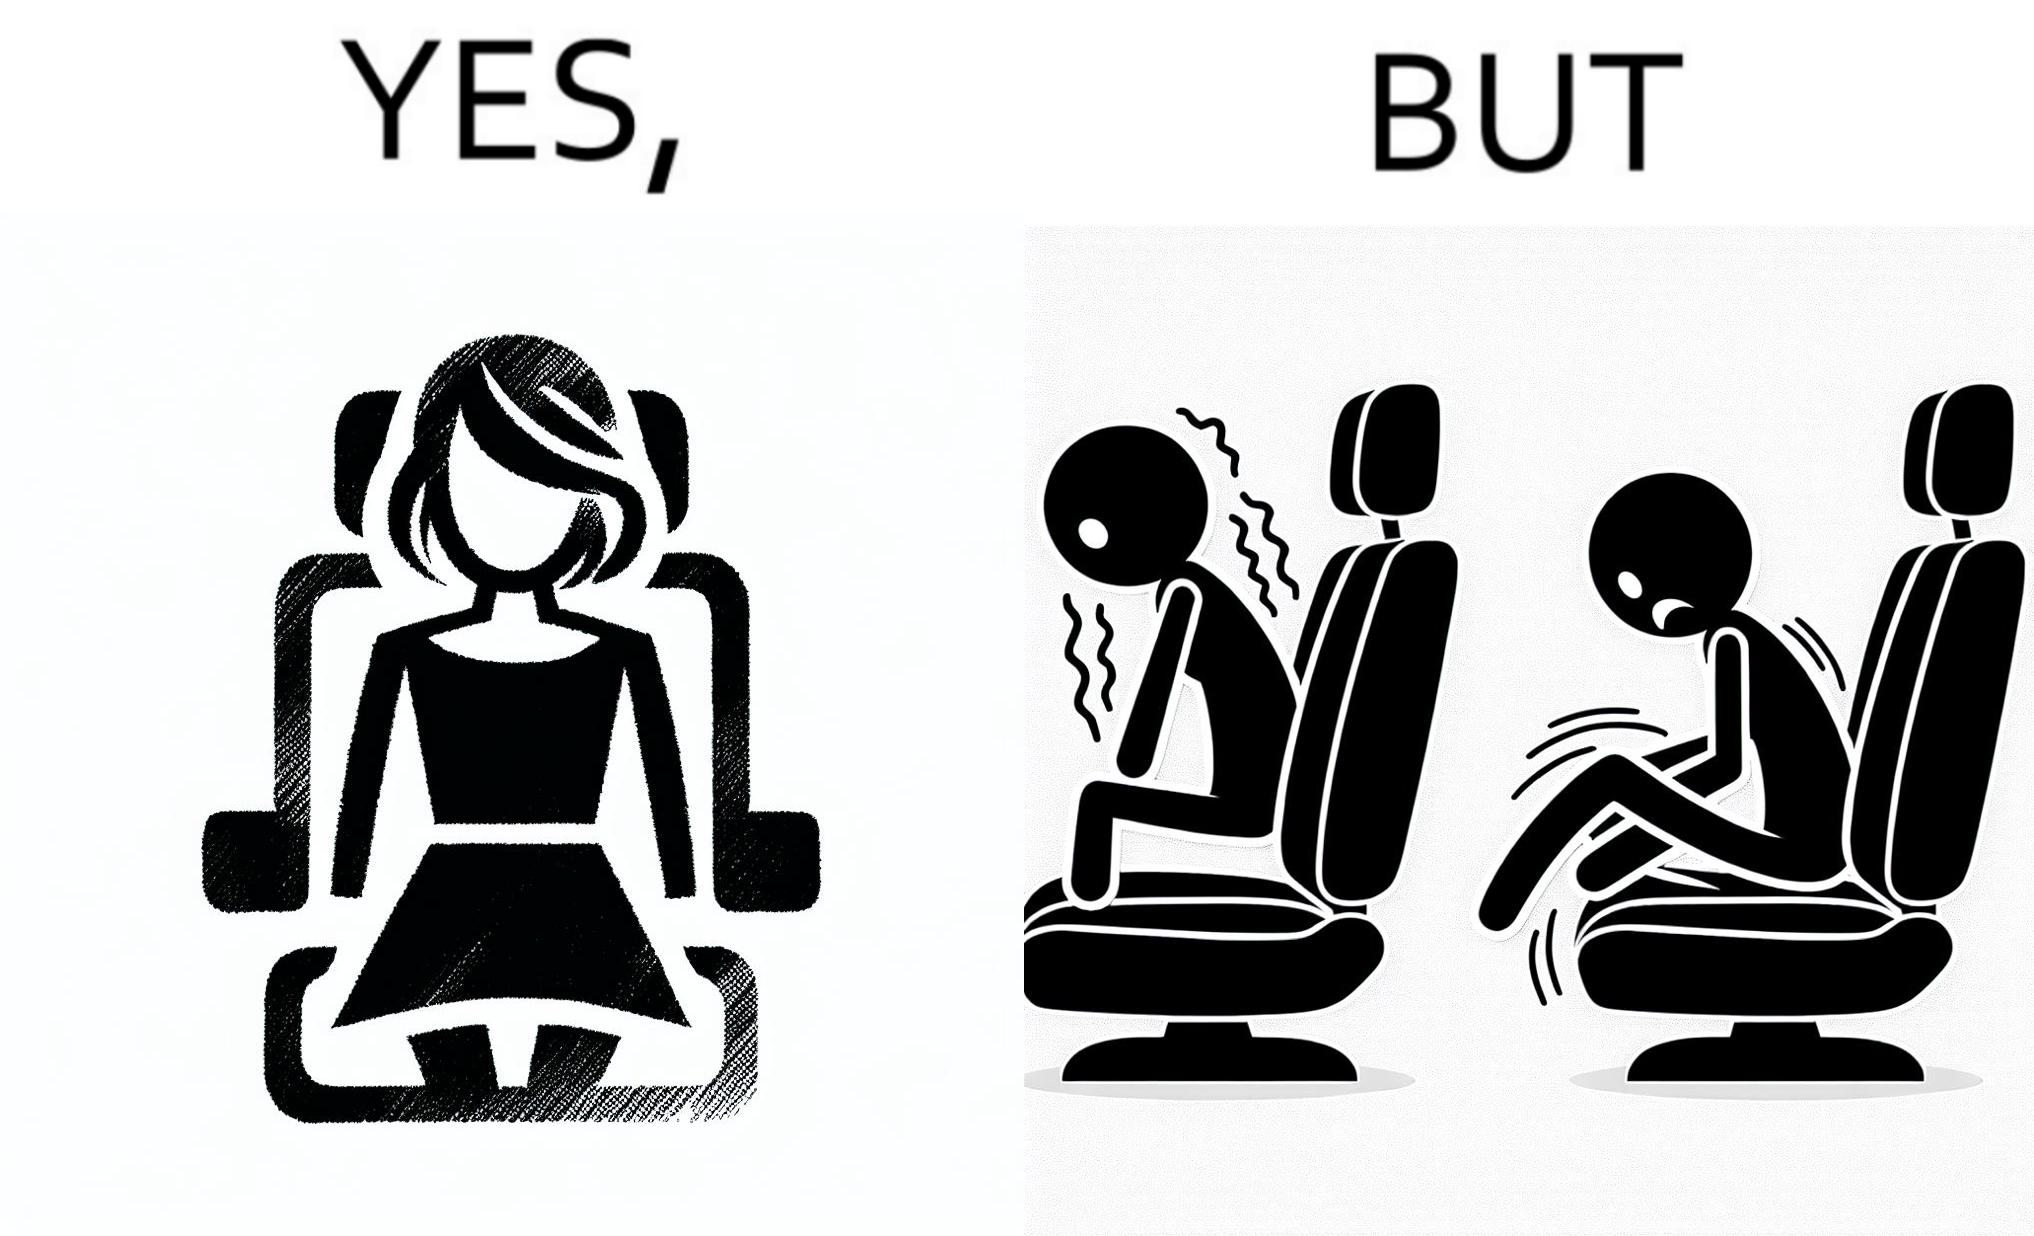Explain the humor or irony in this image. The image is ironic, because the woman is wearing a short dress to look stylish but she had to face inconvenience while travelling in car due to her short dress only. 